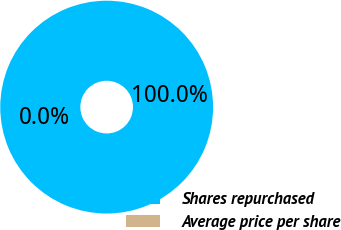Convert chart. <chart><loc_0><loc_0><loc_500><loc_500><pie_chart><fcel>Shares repurchased<fcel>Average price per share<nl><fcel>100.0%<fcel>0.0%<nl></chart> 